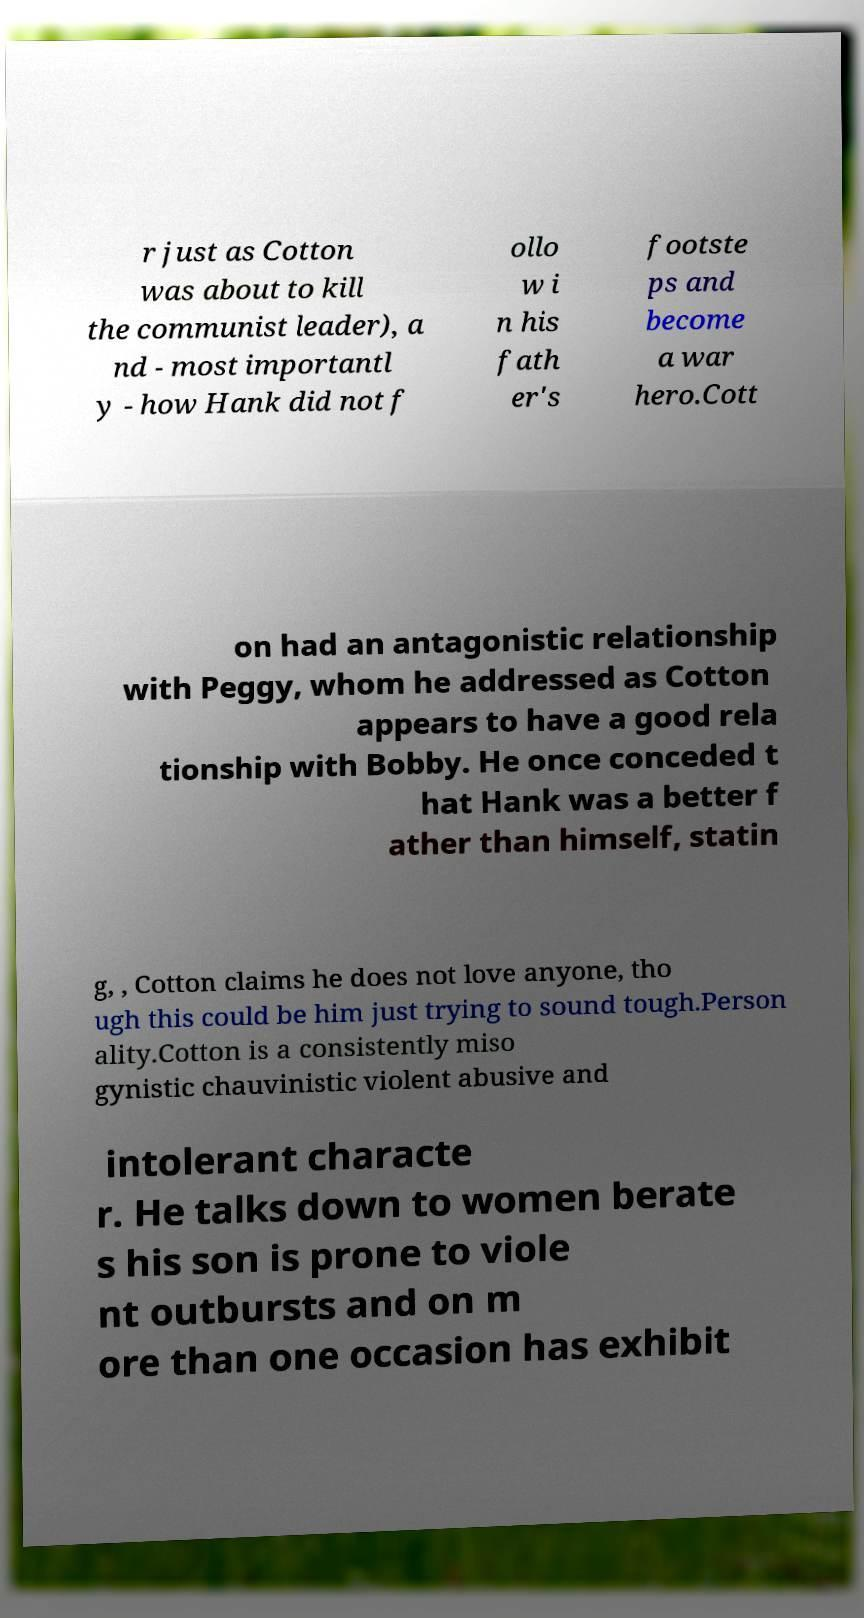Could you extract and type out the text from this image? r just as Cotton was about to kill the communist leader), a nd - most importantl y - how Hank did not f ollo w i n his fath er's footste ps and become a war hero.Cott on had an antagonistic relationship with Peggy, whom he addressed as Cotton appears to have a good rela tionship with Bobby. He once conceded t hat Hank was a better f ather than himself, statin g, , Cotton claims he does not love anyone, tho ugh this could be him just trying to sound tough.Person ality.Cotton is a consistently miso gynistic chauvinistic violent abusive and intolerant characte r. He talks down to women berate s his son is prone to viole nt outbursts and on m ore than one occasion has exhibit 